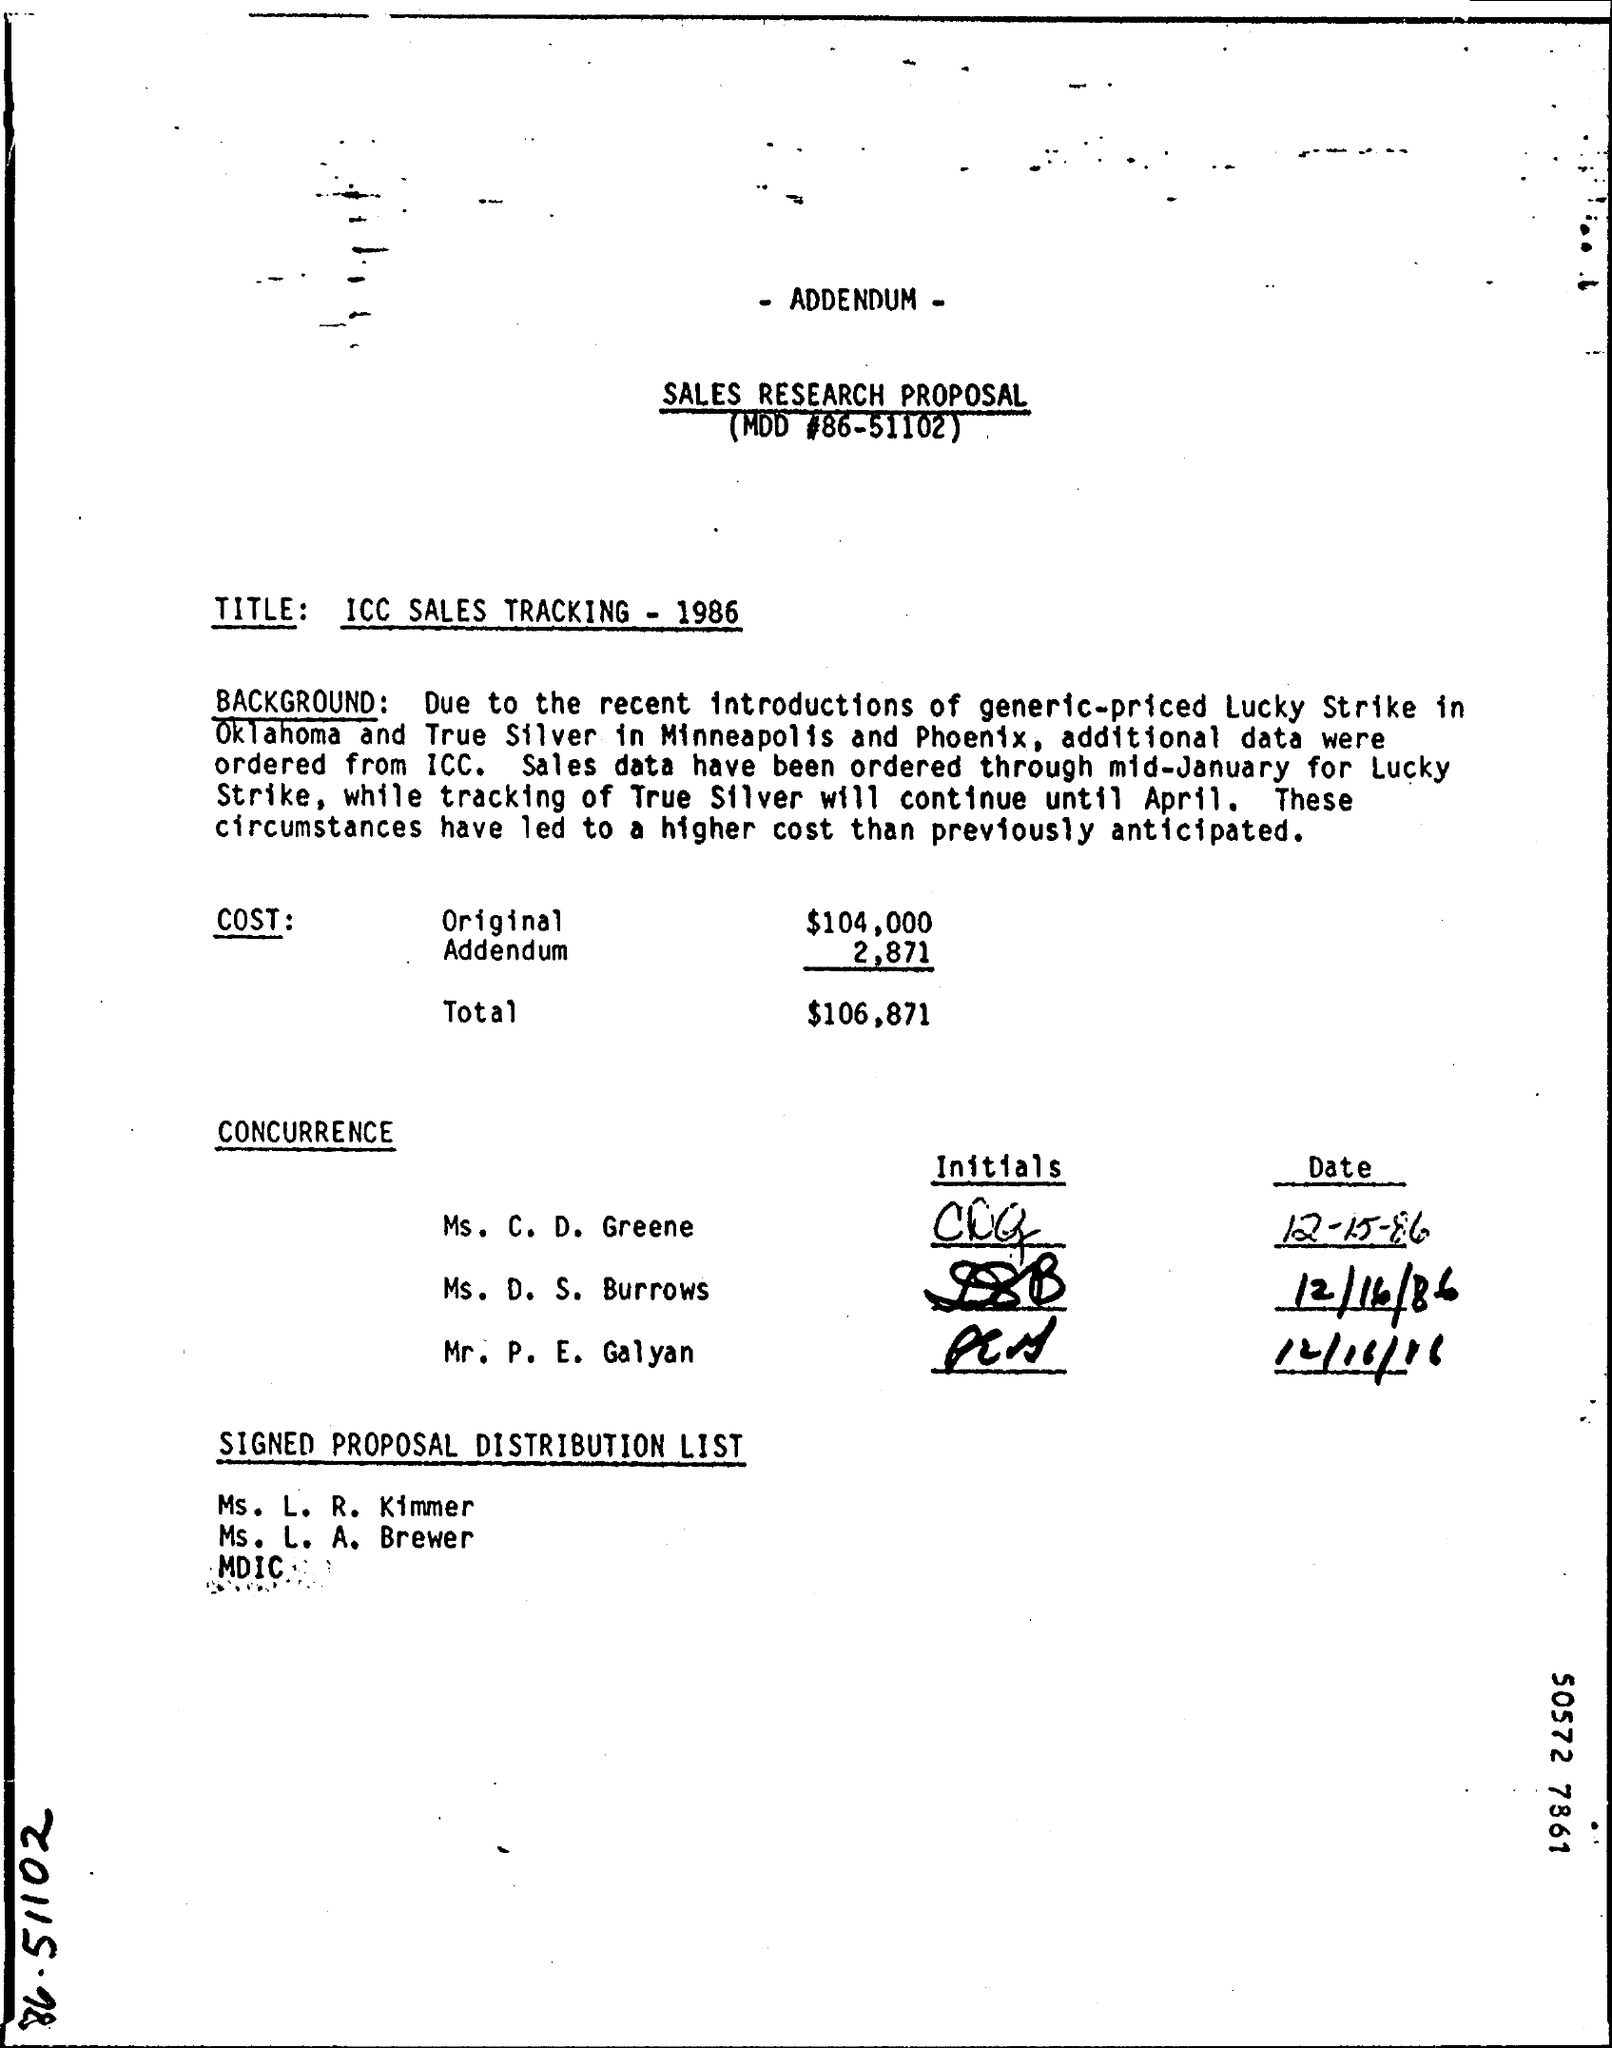Tracking of True silver will continue until which month? According to the Sales Research Proposal, tracking of True Silver is scheduled to continue until April 1986. The document outlines this timeframe in the context of comparing sales data following the introduction of a competing brand in selected markets. 